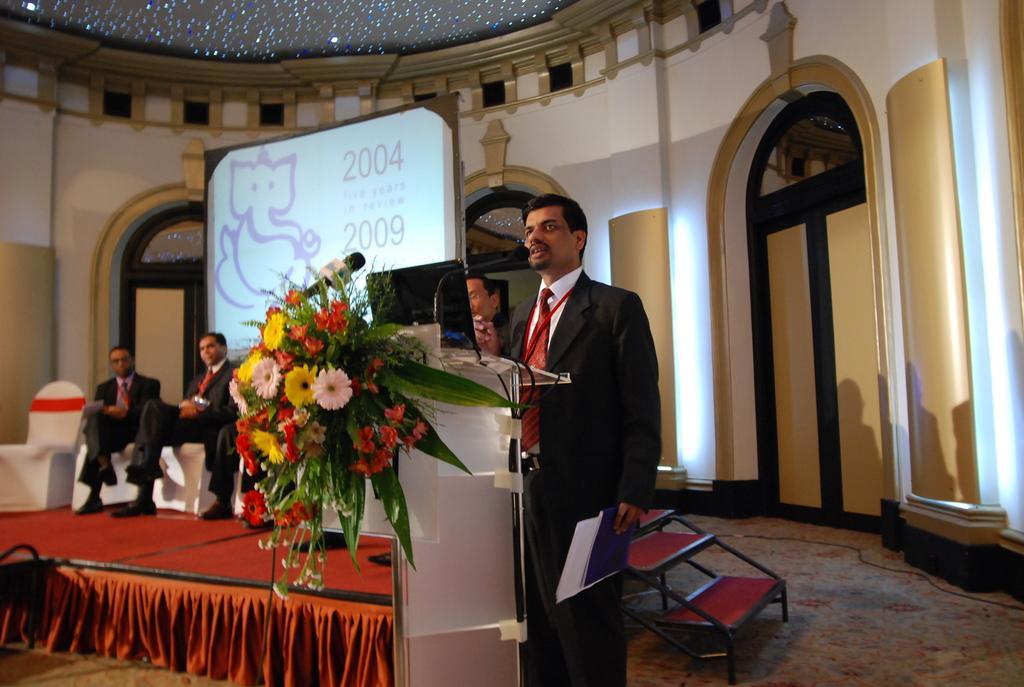Describe this image in one or two sentences. Here we can see a hall with red carpet days,and we can see three people seated on it and one person is standing in front of a podium speaking with the help of a microphone and the podium is decorated with beautiful flowers. 